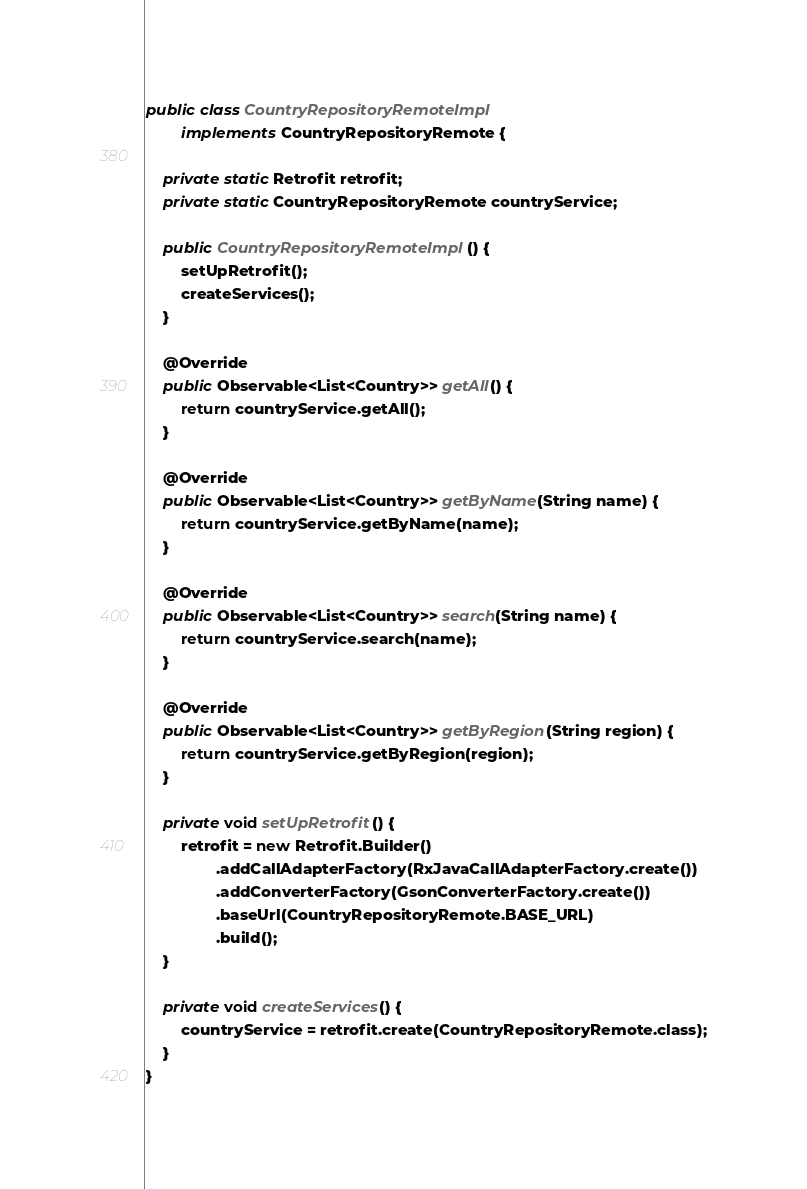Convert code to text. <code><loc_0><loc_0><loc_500><loc_500><_Java_>
public class CountryRepositoryRemoteImpl
        implements CountryRepositoryRemote {

    private static Retrofit retrofit;
    private static CountryRepositoryRemote countryService;

    public CountryRepositoryRemoteImpl() {
        setUpRetrofit();
        createServices();
    }

    @Override
    public Observable<List<Country>> getAll() {
        return countryService.getAll();
    }

    @Override
    public Observable<List<Country>> getByName(String name) {
        return countryService.getByName(name);
    }

    @Override
    public Observable<List<Country>> search(String name) {
        return countryService.search(name);
    }

    @Override
    public Observable<List<Country>> getByRegion(String region) {
        return countryService.getByRegion(region);
    }

    private void setUpRetrofit() {
        retrofit = new Retrofit.Builder()
                .addCallAdapterFactory(RxJavaCallAdapterFactory.create())
                .addConverterFactory(GsonConverterFactory.create())
                .baseUrl(CountryRepositoryRemote.BASE_URL)
                .build();
    }

    private void createServices() {
        countryService = retrofit.create(CountryRepositoryRemote.class);
    }
}
</code> 